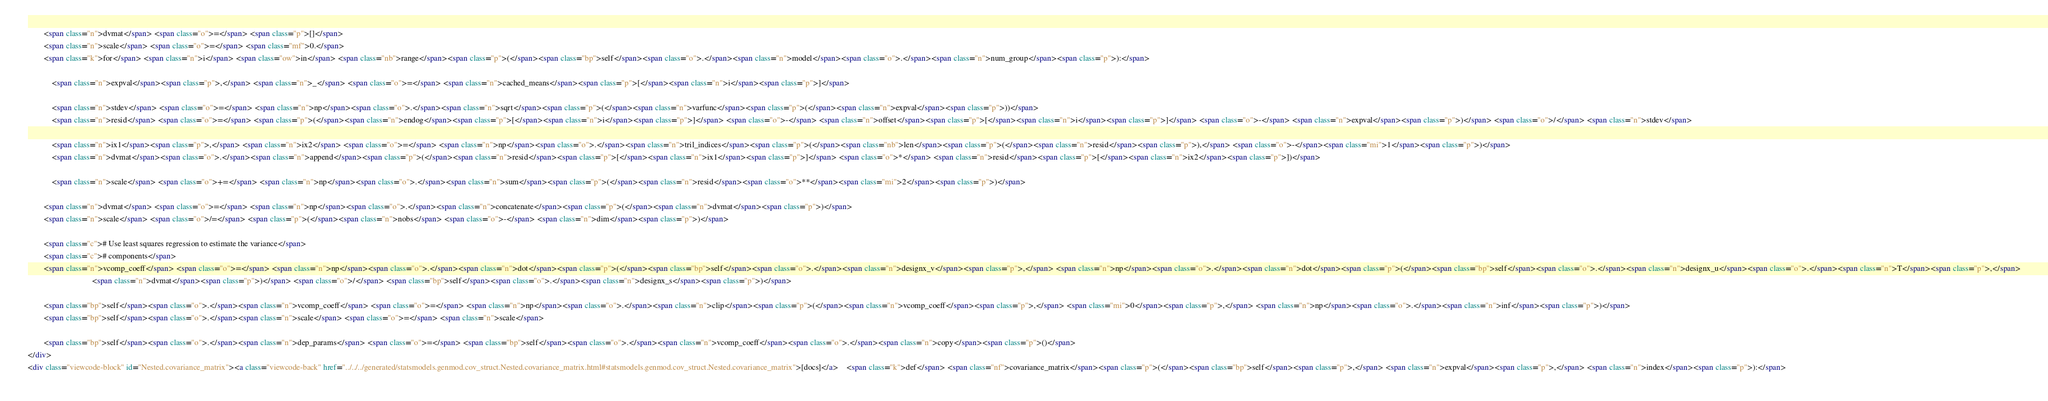<code> <loc_0><loc_0><loc_500><loc_500><_HTML_>
        <span class="n">dvmat</span> <span class="o">=</span> <span class="p">[]</span>
        <span class="n">scale</span> <span class="o">=</span> <span class="mf">0.</span>
        <span class="k">for</span> <span class="n">i</span> <span class="ow">in</span> <span class="nb">range</span><span class="p">(</span><span class="bp">self</span><span class="o">.</span><span class="n">model</span><span class="o">.</span><span class="n">num_group</span><span class="p">):</span>

            <span class="n">expval</span><span class="p">,</span> <span class="n">_</span> <span class="o">=</span> <span class="n">cached_means</span><span class="p">[</span><span class="n">i</span><span class="p">]</span>

            <span class="n">stdev</span> <span class="o">=</span> <span class="n">np</span><span class="o">.</span><span class="n">sqrt</span><span class="p">(</span><span class="n">varfunc</span><span class="p">(</span><span class="n">expval</span><span class="p">))</span>
            <span class="n">resid</span> <span class="o">=</span> <span class="p">(</span><span class="n">endog</span><span class="p">[</span><span class="n">i</span><span class="p">]</span> <span class="o">-</span> <span class="n">offset</span><span class="p">[</span><span class="n">i</span><span class="p">]</span> <span class="o">-</span> <span class="n">expval</span><span class="p">)</span> <span class="o">/</span> <span class="n">stdev</span>

            <span class="n">ix1</span><span class="p">,</span> <span class="n">ix2</span> <span class="o">=</span> <span class="n">np</span><span class="o">.</span><span class="n">tril_indices</span><span class="p">(</span><span class="nb">len</span><span class="p">(</span><span class="n">resid</span><span class="p">),</span> <span class="o">-</span><span class="mi">1</span><span class="p">)</span>
            <span class="n">dvmat</span><span class="o">.</span><span class="n">append</span><span class="p">(</span><span class="n">resid</span><span class="p">[</span><span class="n">ix1</span><span class="p">]</span> <span class="o">*</span> <span class="n">resid</span><span class="p">[</span><span class="n">ix2</span><span class="p">])</span>

            <span class="n">scale</span> <span class="o">+=</span> <span class="n">np</span><span class="o">.</span><span class="n">sum</span><span class="p">(</span><span class="n">resid</span><span class="o">**</span><span class="mi">2</span><span class="p">)</span>

        <span class="n">dvmat</span> <span class="o">=</span> <span class="n">np</span><span class="o">.</span><span class="n">concatenate</span><span class="p">(</span><span class="n">dvmat</span><span class="p">)</span>
        <span class="n">scale</span> <span class="o">/=</span> <span class="p">(</span><span class="n">nobs</span> <span class="o">-</span> <span class="n">dim</span><span class="p">)</span>

        <span class="c"># Use least squares regression to estimate the variance</span>
        <span class="c"># components</span>
        <span class="n">vcomp_coeff</span> <span class="o">=</span> <span class="n">np</span><span class="o">.</span><span class="n">dot</span><span class="p">(</span><span class="bp">self</span><span class="o">.</span><span class="n">designx_v</span><span class="p">,</span> <span class="n">np</span><span class="o">.</span><span class="n">dot</span><span class="p">(</span><span class="bp">self</span><span class="o">.</span><span class="n">designx_u</span><span class="o">.</span><span class="n">T</span><span class="p">,</span>
                                <span class="n">dvmat</span><span class="p">)</span> <span class="o">/</span> <span class="bp">self</span><span class="o">.</span><span class="n">designx_s</span><span class="p">)</span>

        <span class="bp">self</span><span class="o">.</span><span class="n">vcomp_coeff</span> <span class="o">=</span> <span class="n">np</span><span class="o">.</span><span class="n">clip</span><span class="p">(</span><span class="n">vcomp_coeff</span><span class="p">,</span> <span class="mi">0</span><span class="p">,</span> <span class="n">np</span><span class="o">.</span><span class="n">inf</span><span class="p">)</span>
        <span class="bp">self</span><span class="o">.</span><span class="n">scale</span> <span class="o">=</span> <span class="n">scale</span>

        <span class="bp">self</span><span class="o">.</span><span class="n">dep_params</span> <span class="o">=</span> <span class="bp">self</span><span class="o">.</span><span class="n">vcomp_coeff</span><span class="o">.</span><span class="n">copy</span><span class="p">()</span>
</div>
<div class="viewcode-block" id="Nested.covariance_matrix"><a class="viewcode-back" href="../../../generated/statsmodels.genmod.cov_struct.Nested.covariance_matrix.html#statsmodels.genmod.cov_struct.Nested.covariance_matrix">[docs]</a>    <span class="k">def</span> <span class="nf">covariance_matrix</span><span class="p">(</span><span class="bp">self</span><span class="p">,</span> <span class="n">expval</span><span class="p">,</span> <span class="n">index</span><span class="p">):</span>
</code> 